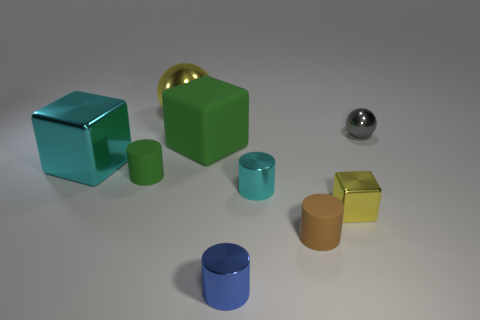There is a thing that is right of the yellow thing that is to the right of the cyan thing to the right of the blue cylinder; what is its material? The object to the right of the yellow cube, which in turn is to the right of the cyan cube adjacent to the right of the blue cylinder, appears to be a sphere made of a shiny, reflective material, which looks like metal. 